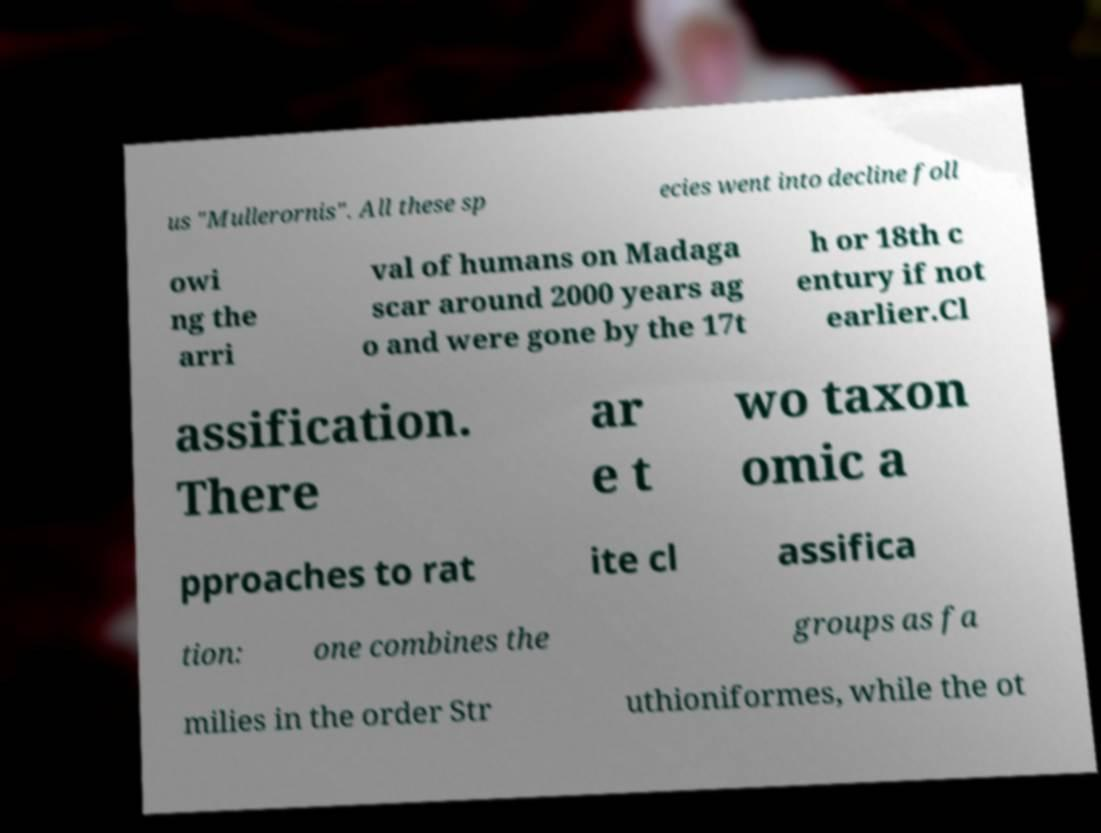There's text embedded in this image that I need extracted. Can you transcribe it verbatim? us "Mullerornis". All these sp ecies went into decline foll owi ng the arri val of humans on Madaga scar around 2000 years ag o and were gone by the 17t h or 18th c entury if not earlier.Cl assification. There ar e t wo taxon omic a pproaches to rat ite cl assifica tion: one combines the groups as fa milies in the order Str uthioniformes, while the ot 